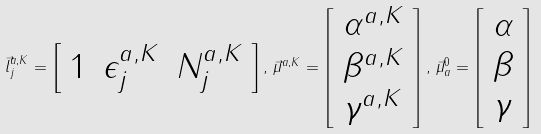<formula> <loc_0><loc_0><loc_500><loc_500>\vec { l } _ { j } ^ { a , K } = \left [ \begin{array} { c c c } 1 & \epsilon _ { j } ^ { a , K } & N _ { j } ^ { a , K } \end{array} \right ] , \, \vec { \mu } ^ { a , K } = \left [ \begin{array} { c } \alpha ^ { a , K } \\ \beta ^ { a , K } \\ \gamma ^ { a , K } \end{array} \right ] , \, \vec { \mu } _ { a } ^ { 0 } = \left [ \begin{array} { c } \alpha \\ \beta \\ \gamma \end{array} \right ]</formula> 